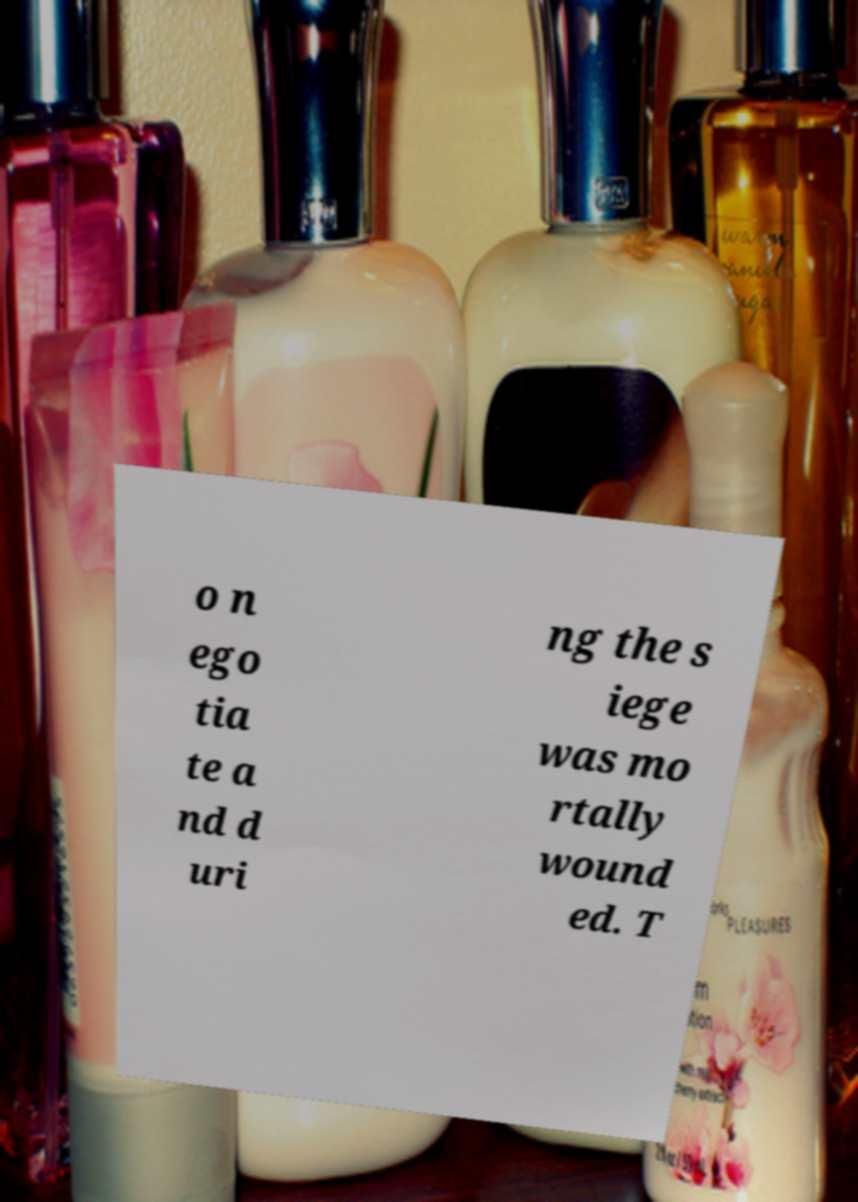I need the written content from this picture converted into text. Can you do that? o n ego tia te a nd d uri ng the s iege was mo rtally wound ed. T 